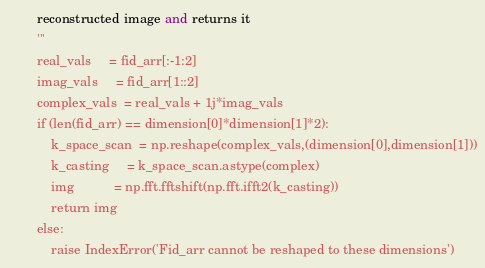Convert code to text. <code><loc_0><loc_0><loc_500><loc_500><_Python_>        reconstructed image and returns it
        ''' 
        real_vals     = fid_arr[:-1:2]
        imag_vals     = fid_arr[1::2]
        complex_vals  = real_vals + 1j*imag_vals
        if (len(fid_arr) == dimension[0]*dimension[1]*2):
            k_space_scan  = np.reshape(complex_vals,(dimension[0],dimension[1]))
            k_casting     = k_space_scan.astype(complex)
            img           = np.fft.fftshift(np.fft.ifft2(k_casting)) 
            return img
        else:
            raise IndexError('Fid_arr cannot be reshaped to these dimensions')</code> 